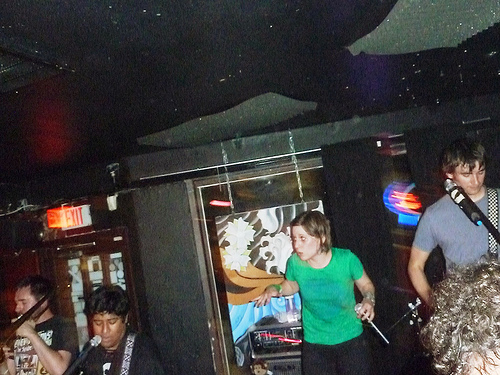<image>
Is there a sign behind the man? Yes. From this viewpoint, the sign is positioned behind the man, with the man partially or fully occluding the sign. Is there a microphone in front of the woman? Yes. The microphone is positioned in front of the woman, appearing closer to the camera viewpoint. 